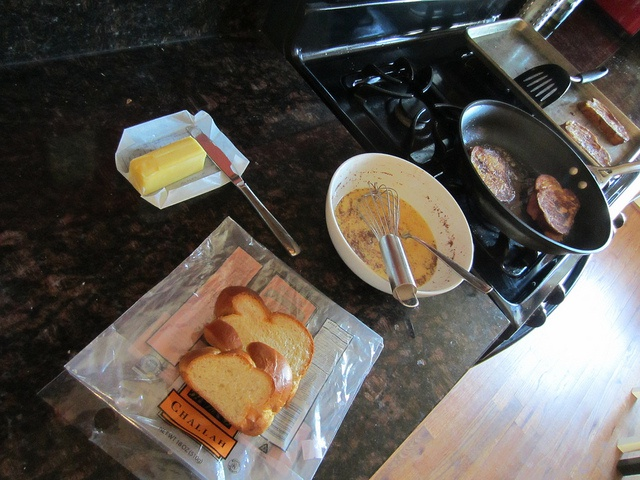Describe the objects in this image and their specific colors. I can see oven in black, gray, navy, and blue tones, bowl in black, tan, gray, and lightgray tones, knife in black, brown, gray, and darkgray tones, and spoon in black and gray tones in this image. 